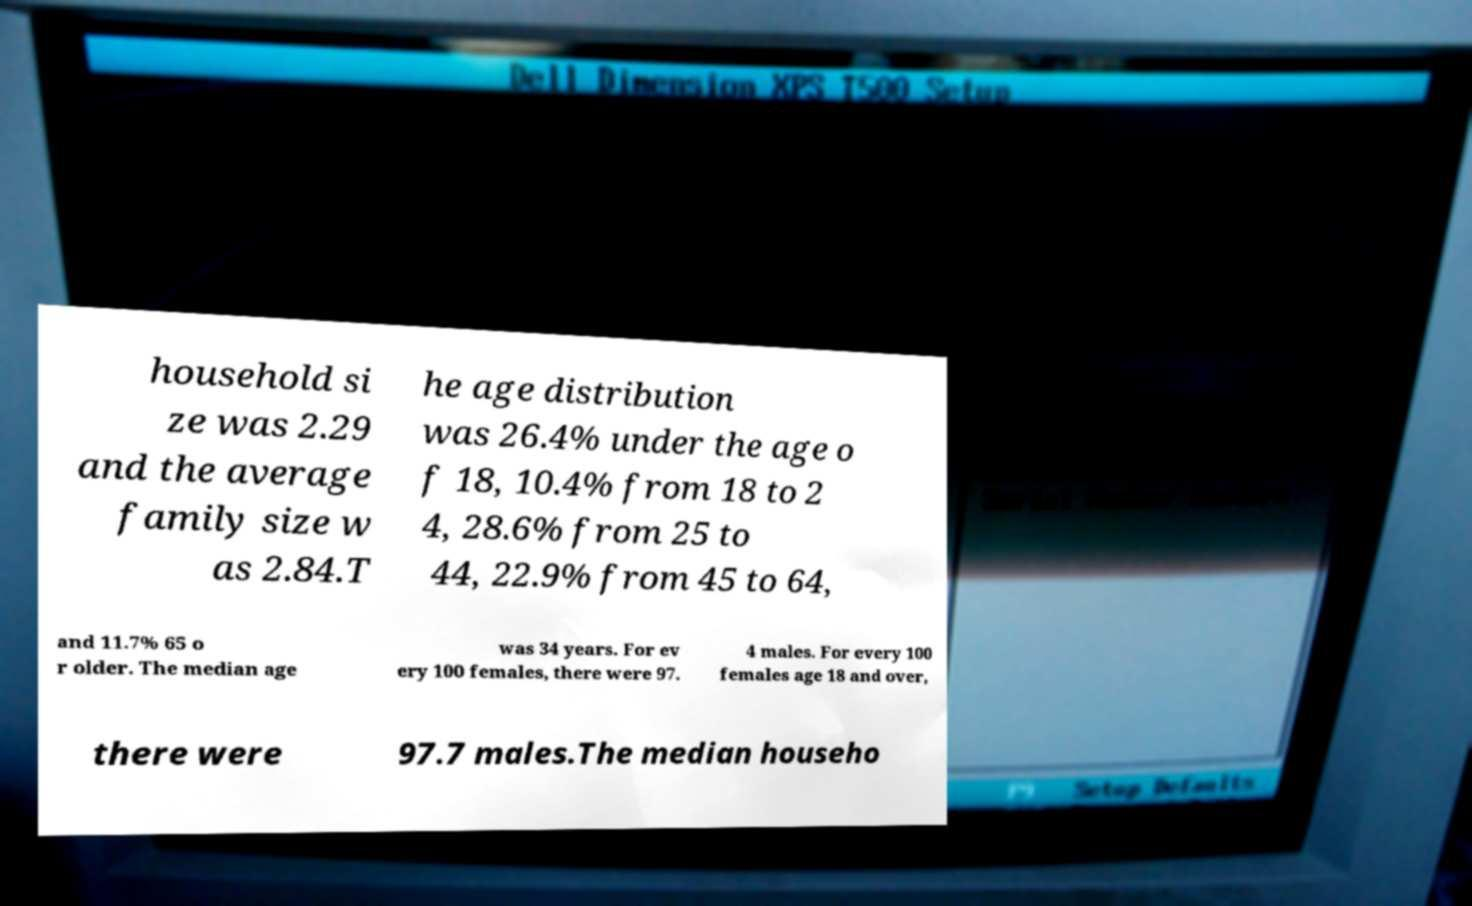Can you read and provide the text displayed in the image?This photo seems to have some interesting text. Can you extract and type it out for me? household si ze was 2.29 and the average family size w as 2.84.T he age distribution was 26.4% under the age o f 18, 10.4% from 18 to 2 4, 28.6% from 25 to 44, 22.9% from 45 to 64, and 11.7% 65 o r older. The median age was 34 years. For ev ery 100 females, there were 97. 4 males. For every 100 females age 18 and over, there were 97.7 males.The median househo 